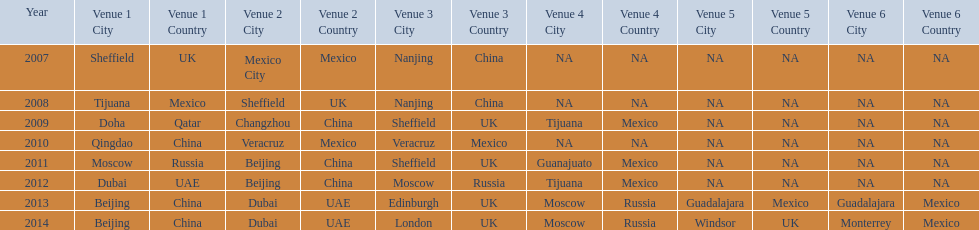Which year had more venues, 2007 or 2012? 2012. 